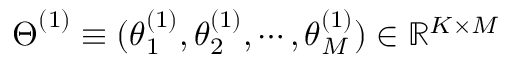<formula> <loc_0><loc_0><loc_500><loc_500>{ \boldsymbol \Theta } ^ { ( 1 ) } \equiv ( { \boldsymbol \theta } _ { 1 } ^ { ( 1 ) } , { \boldsymbol \theta } _ { 2 } ^ { ( 1 ) } , \cdots , { \boldsymbol \theta } _ { M } ^ { ( 1 ) } ) \in \mathbb { R } ^ { K \times M }</formula> 